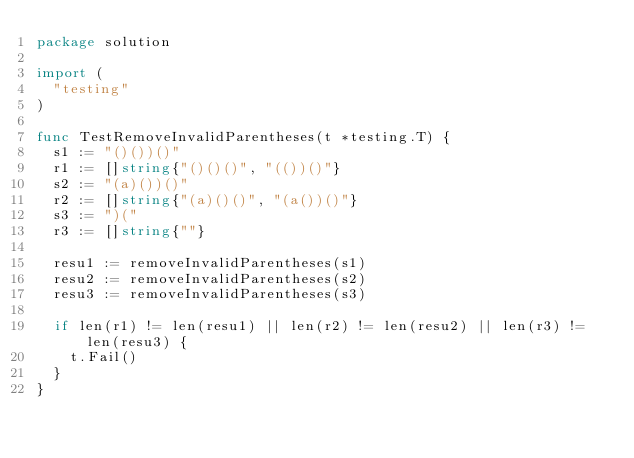Convert code to text. <code><loc_0><loc_0><loc_500><loc_500><_Go_>package solution

import (
	"testing"
)

func TestRemoveInvalidParentheses(t *testing.T) {
	s1 := "()())()"
	r1 := []string{"()()()", "(())()"}
	s2 := "(a)())()"
	r2 := []string{"(a)()()", "(a())()"}
	s3 := ")("
	r3 := []string{""}

	resu1 := removeInvalidParentheses(s1)
	resu2 := removeInvalidParentheses(s2)
	resu3 := removeInvalidParentheses(s3)

	if len(r1) != len(resu1) || len(r2) != len(resu2) || len(r3) != len(resu3) {
		t.Fail()
	}
}
</code> 